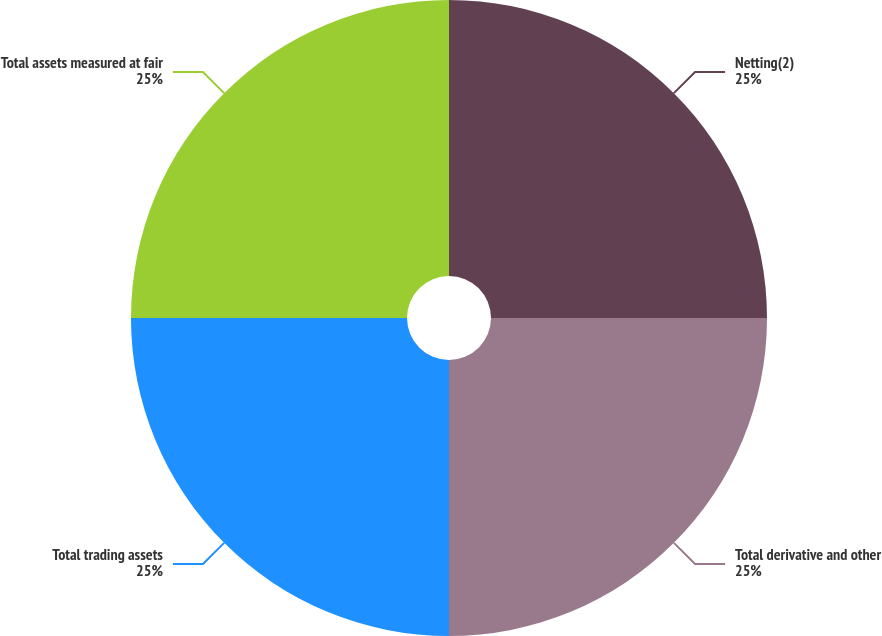Convert chart. <chart><loc_0><loc_0><loc_500><loc_500><pie_chart><fcel>Netting(2)<fcel>Total derivative and other<fcel>Total trading assets<fcel>Total assets measured at fair<nl><fcel>25.0%<fcel>25.0%<fcel>25.0%<fcel>25.0%<nl></chart> 